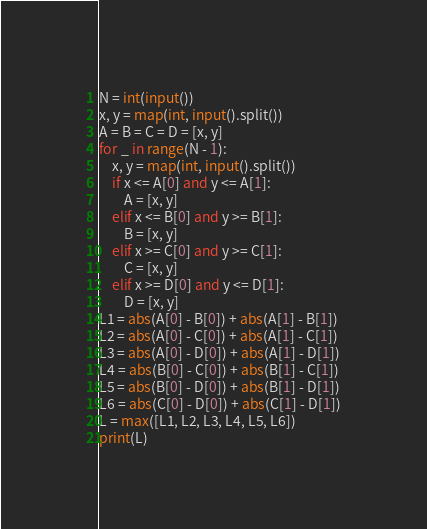Convert code to text. <code><loc_0><loc_0><loc_500><loc_500><_Python_>N = int(input())
x, y = map(int, input().split())
A = B = C = D = [x, y]
for _ in range(N - 1):
    x, y = map(int, input().split())
    if x <= A[0] and y <= A[1]:
        A = [x, y]
    elif x <= B[0] and y >= B[1]:
        B = [x, y]
    elif x >= C[0] and y >= C[1]:
        C = [x, y]
    elif x >= D[0] and y <= D[1]:
        D = [x, y]
L1 = abs(A[0] - B[0]) + abs(A[1] - B[1])
L2 = abs(A[0] - C[0]) + abs(A[1] - C[1])
L3 = abs(A[0] - D[0]) + abs(A[1] - D[1])
L4 = abs(B[0] - C[0]) + abs(B[1] - C[1])
L5 = abs(B[0] - D[0]) + abs(B[1] - D[1])
L6 = abs(C[0] - D[0]) + abs(C[1] - D[1])
L = max([L1, L2, L3, L4, L5, L6])
print(L)</code> 